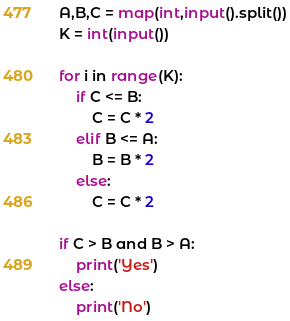Convert code to text. <code><loc_0><loc_0><loc_500><loc_500><_Python_>A,B,C = map(int,input().split())
K = int(input())

for i in range(K):
    if C <= B:
        C = C * 2
    elif B <= A:
        B = B * 2
    else:
        C = C * 2

if C > B and B > A:
    print('Yes')
else:
    print('No')</code> 